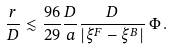Convert formula to latex. <formula><loc_0><loc_0><loc_500><loc_500>\frac { r } { D } \lesssim \frac { 9 6 } { 2 9 } \frac { D } { a } \frac { D } { | \xi ^ { F } - \xi ^ { B } | } \, \Phi \, .</formula> 